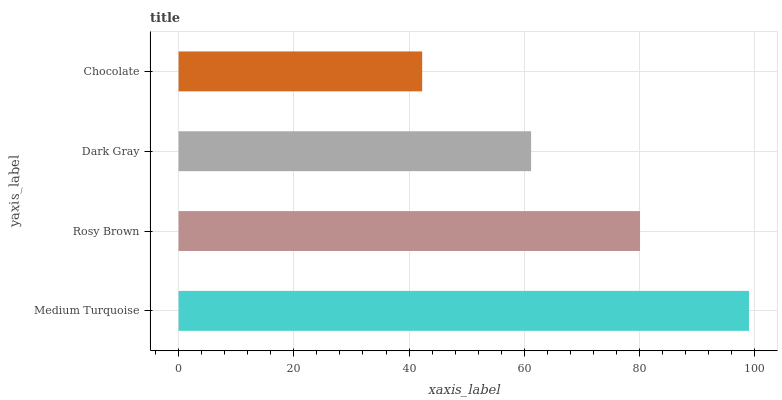Is Chocolate the minimum?
Answer yes or no. Yes. Is Medium Turquoise the maximum?
Answer yes or no. Yes. Is Rosy Brown the minimum?
Answer yes or no. No. Is Rosy Brown the maximum?
Answer yes or no. No. Is Medium Turquoise greater than Rosy Brown?
Answer yes or no. Yes. Is Rosy Brown less than Medium Turquoise?
Answer yes or no. Yes. Is Rosy Brown greater than Medium Turquoise?
Answer yes or no. No. Is Medium Turquoise less than Rosy Brown?
Answer yes or no. No. Is Rosy Brown the high median?
Answer yes or no. Yes. Is Dark Gray the low median?
Answer yes or no. Yes. Is Medium Turquoise the high median?
Answer yes or no. No. Is Chocolate the low median?
Answer yes or no. No. 